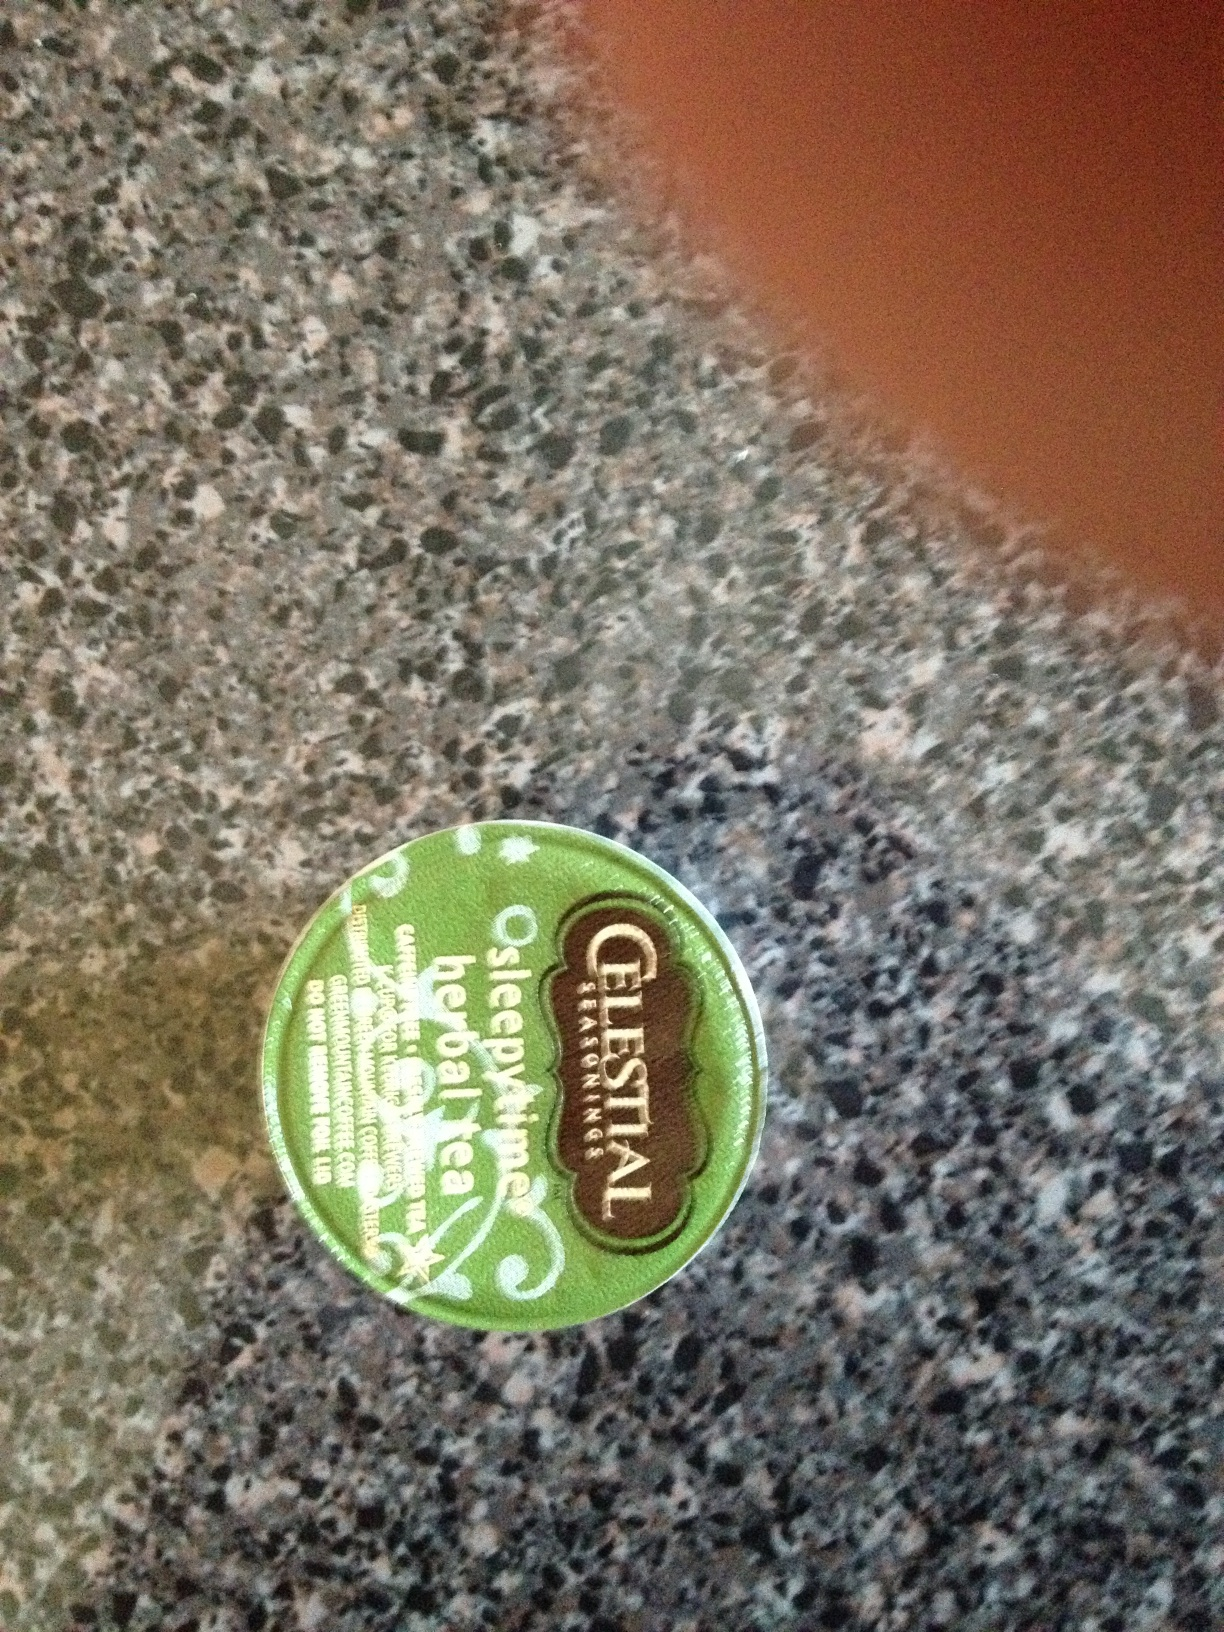What are some of the ingredients listed on this tea container? The tea contains chamomile, spearmint, lemongrass, tilia flowers, blackberry leaves, orange blossoms, hawthorn, and rosebuds. 